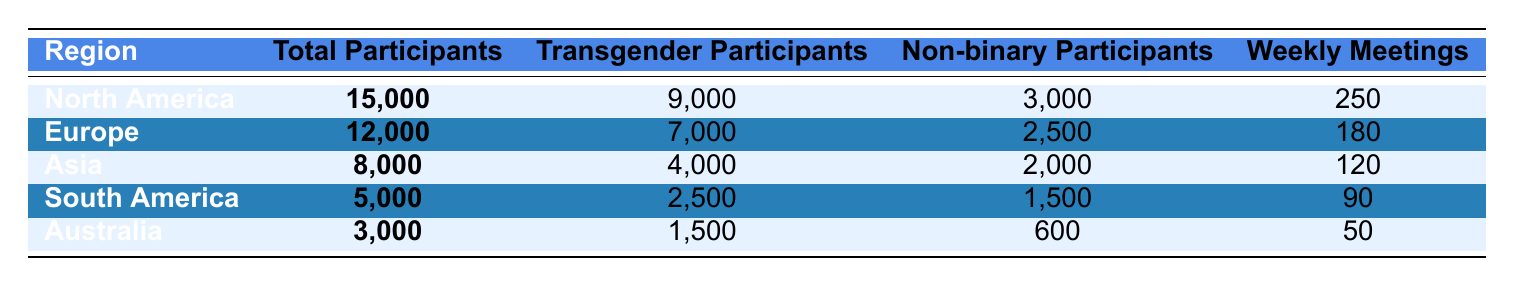What is the total number of participants in North America? The table lists the total participants in North America as **15,000** in the corresponding row.
Answer: 15,000 How many non-binary participants are there in Europe? Referring to the Europe row in the table shows **2,500** non-binary participants.
Answer: 2,500 Which region has the highest number of weekly meetings? By comparing the values in the Weekly Meetings column, North America has **250** meetings, which is the highest among all regions.
Answer: North America What is the total number of transgender participants across all regions? Summing up the transgender participants: 9,000 (North America) + 7,000 (Europe) + 4,000 (Asia) + 2,500 (South America) + 1,500 (Australia) equals **24,000**.
Answer: 24,000 How many more total participants are there in North America than in South America? The total participants in North America is **15,000**, and in South America, it's **5,000**. The difference is 15,000 - 5,000 = **10,000**.
Answer: 10,000 Is the number of non-binary participants in Asia greater than that in Australia? Asia has **2,000** non-binary participants while Australia has **600**. Since 2,000 > 600, the statement is true.
Answer: Yes What is the average number of total participants across all regions? Adding the total participants: 15,000 + 12,000 + 8,000 + 5,000 + 3,000 gives **43,000**. Dividing by the number of regions (5) results in an average of 43,000 / 5 = **8,600**.
Answer: 8,600 Which region has the lowest number of transgender participants? The smallest number in the Transgender Participants column is **1,500** from Australia.
Answer: Australia How many total participants are there in Asia compared to Europe? Asia has **8,000** total participants while Europe has **12,000**. Comparing these shows that Europe has more participants, specifically 12,000 - 8,000 = **4,000** more.
Answer: 4,000 Is the ratio of transgender participants to non-binary participants higher in North America than in South America? In North America, the ratio is 9,000 transgender to 3,000 non-binary, which simplifies to 3:1. In South America, it’s 2,500 transgender to 1,500 non-binary, which simplifies to 5:3 (approximately 1.67:1). Since 3:1 is greater than 1.67:1, the statement is true.
Answer: Yes 